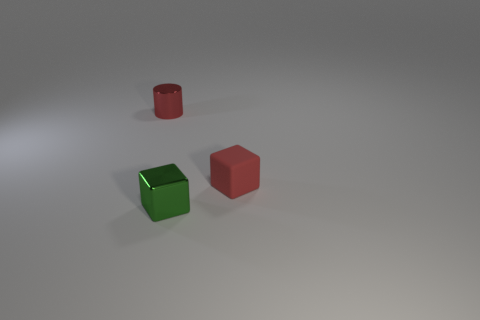Are there any red things that have the same size as the red matte block?
Your response must be concise. Yes. Does the thing that is on the left side of the small green cube have the same color as the metallic block?
Keep it short and to the point. No. How many things are small red rubber balls or small green metal objects?
Your answer should be compact. 1. How many other things are there of the same shape as the green metal object?
Keep it short and to the point. 1. What number of other objects are there of the same material as the small cylinder?
Give a very brief answer. 1. There is a red thing that is the same shape as the green metal thing; what size is it?
Offer a terse response. Small. Does the matte cube have the same color as the tiny metallic cylinder?
Keep it short and to the point. Yes. The tiny object that is both right of the red metal cylinder and behind the small green metal thing is what color?
Offer a terse response. Red. How many things are either things that are in front of the red matte object or big green things?
Provide a succinct answer. 1. There is another thing that is the same shape as the rubber object; what is its color?
Your response must be concise. Green. 